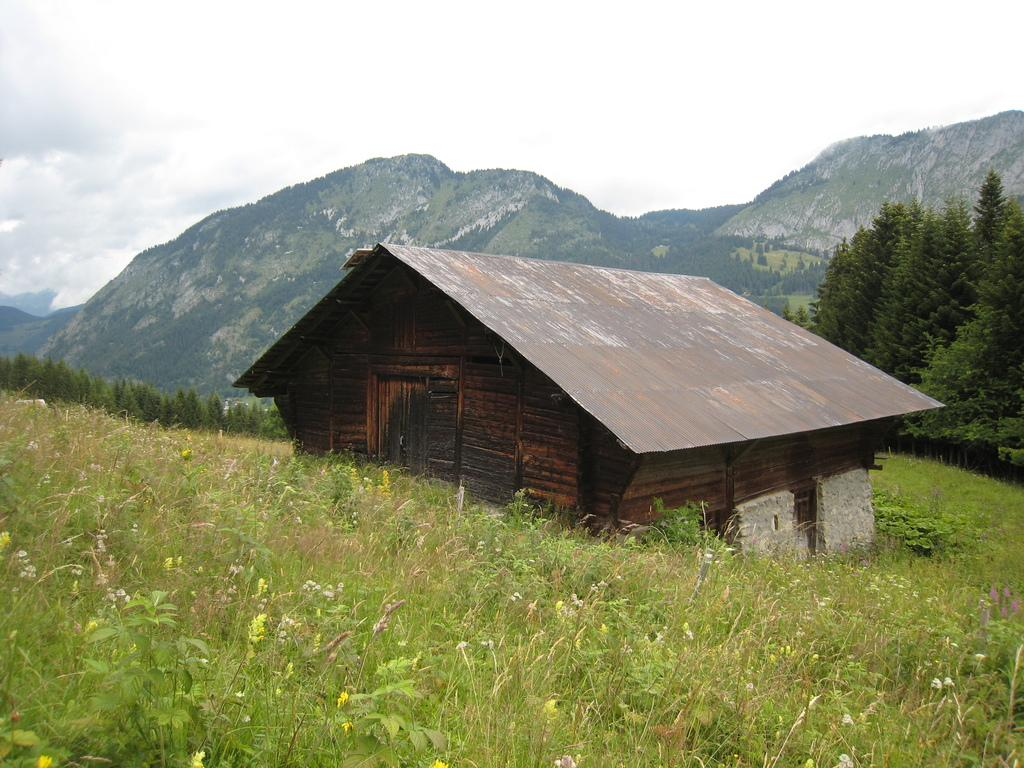What type of house is in the center of the image? There is a wooden house in the center of the image. Can you describe the surroundings of the house in the image? There is greenery around the area of the image. What type of test can be seen being conducted in the image? There is no test being conducted in the image; it only shows a wooden house and greenery. 